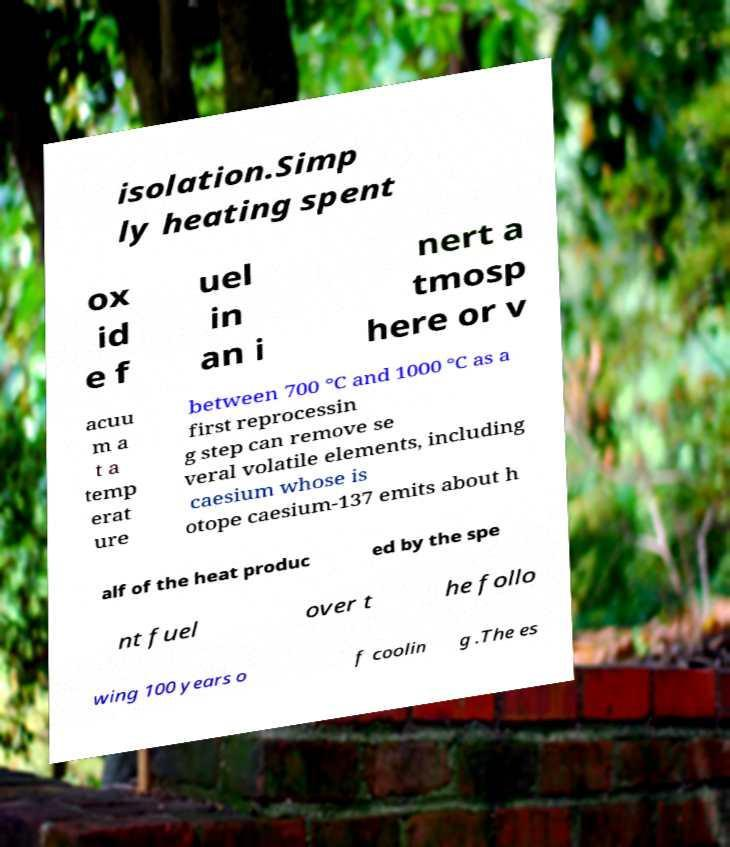Can you accurately transcribe the text from the provided image for me? isolation.Simp ly heating spent ox id e f uel in an i nert a tmosp here or v acuu m a t a temp erat ure between 700 °C and 1000 °C as a first reprocessin g step can remove se veral volatile elements, including caesium whose is otope caesium-137 emits about h alf of the heat produc ed by the spe nt fuel over t he follo wing 100 years o f coolin g .The es 